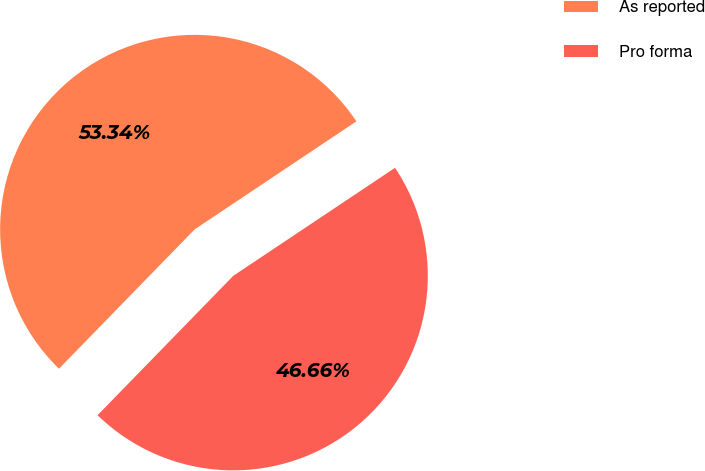Convert chart to OTSL. <chart><loc_0><loc_0><loc_500><loc_500><pie_chart><fcel>As reported<fcel>Pro forma<nl><fcel>53.34%<fcel>46.66%<nl></chart> 